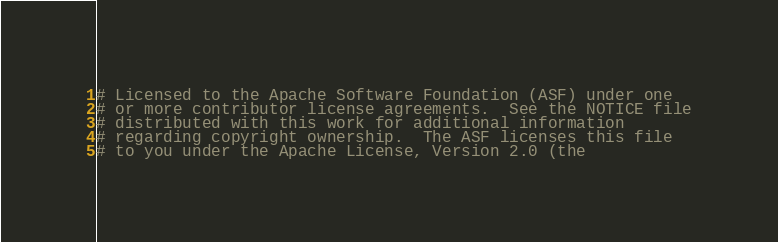Convert code to text. <code><loc_0><loc_0><loc_500><loc_500><_Python_># Licensed to the Apache Software Foundation (ASF) under one
# or more contributor license agreements.  See the NOTICE file
# distributed with this work for additional information
# regarding copyright ownership.  The ASF licenses this file
# to you under the Apache License, Version 2.0 (the</code> 